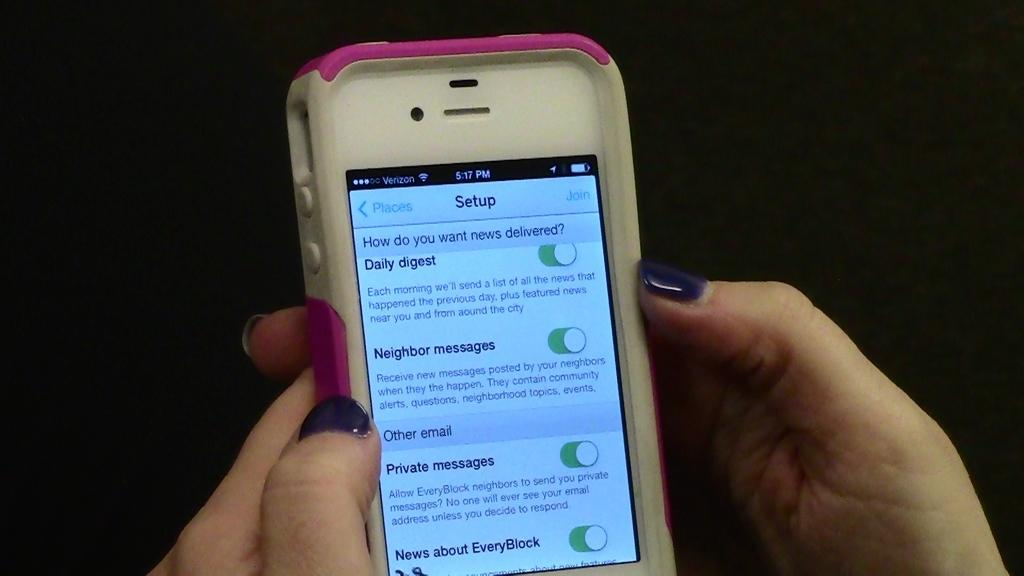<image>
Describe the image concisely. A woman holds a white smart phone with a setup screen on its display. 